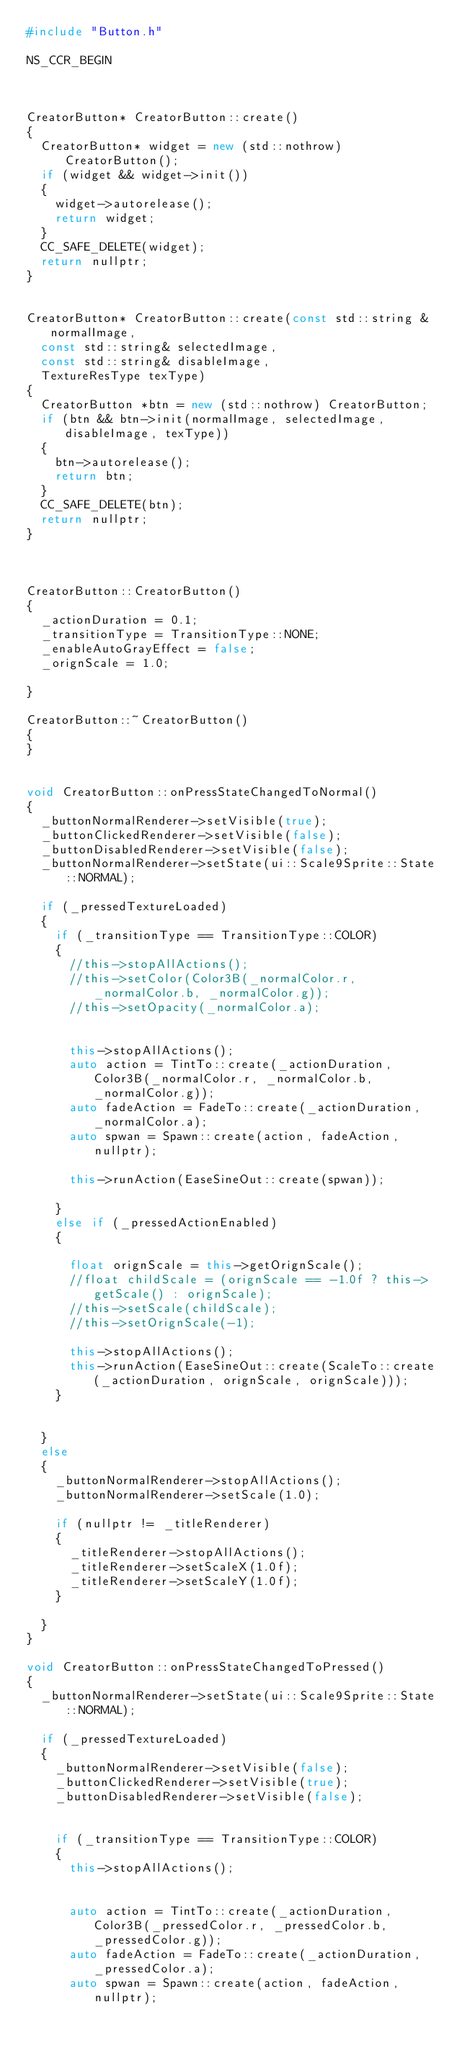<code> <loc_0><loc_0><loc_500><loc_500><_C++_>#include "Button.h"

NS_CCR_BEGIN



CreatorButton* CreatorButton::create()
{
	CreatorButton* widget = new (std::nothrow) CreatorButton();
	if (widget && widget->init())
	{
		widget->autorelease();
		return widget;
	}
	CC_SAFE_DELETE(widget);
	return nullptr;
}


CreatorButton* CreatorButton::create(const std::string &normalImage,
	const std::string& selectedImage,
	const std::string& disableImage,
	TextureResType texType)
{
	CreatorButton *btn = new (std::nothrow) CreatorButton;
	if (btn && btn->init(normalImage, selectedImage, disableImage, texType))
	{
		btn->autorelease();
		return btn;
	}
	CC_SAFE_DELETE(btn);
	return nullptr;
}



CreatorButton::CreatorButton()
{
	_actionDuration = 0.1;
	_transitionType = TransitionType::NONE;
	_enableAutoGrayEffect = false;
	_orignScale = 1.0;

}

CreatorButton::~CreatorButton()
{
}


void CreatorButton::onPressStateChangedToNormal()
{
	_buttonNormalRenderer->setVisible(true);
	_buttonClickedRenderer->setVisible(false);
	_buttonDisabledRenderer->setVisible(false);
	_buttonNormalRenderer->setState(ui::Scale9Sprite::State::NORMAL);

	if (_pressedTextureLoaded)
	{
		if (_transitionType == TransitionType::COLOR)
		{
			//this->stopAllActions();
			//this->setColor(Color3B(_normalColor.r, _normalColor.b, _normalColor.g));
			//this->setOpacity(_normalColor.a);


			this->stopAllActions();
			auto action = TintTo::create(_actionDuration, Color3B(_normalColor.r, _normalColor.b, _normalColor.g));
			auto fadeAction = FadeTo::create(_actionDuration, _normalColor.a);
			auto spwan = Spawn::create(action, fadeAction, nullptr);

			this->runAction(EaseSineOut::create(spwan));

		}
		else if (_pressedActionEnabled)
		{
			
			float orignScale = this->getOrignScale();
			//float childScale = (orignScale == -1.0f ? this->getScale() : orignScale);
			//this->setScale(childScale);
			//this->setOrignScale(-1);

			this->stopAllActions();
			this->runAction(EaseSineOut::create(ScaleTo::create(_actionDuration, orignScale, orignScale)));
		}


	}
	else
	{
		_buttonNormalRenderer->stopAllActions();
		_buttonNormalRenderer->setScale(1.0);

		if (nullptr != _titleRenderer)
		{
			_titleRenderer->stopAllActions();
			_titleRenderer->setScaleX(1.0f);
			_titleRenderer->setScaleY(1.0f);
		}

	}
}

void CreatorButton::onPressStateChangedToPressed()
{
	_buttonNormalRenderer->setState(ui::Scale9Sprite::State::NORMAL);

	if (_pressedTextureLoaded)
	{
		_buttonNormalRenderer->setVisible(false);
		_buttonClickedRenderer->setVisible(true);
		_buttonDisabledRenderer->setVisible(false);


		if (_transitionType == TransitionType::COLOR)
		{
			this->stopAllActions();


			auto action = TintTo::create(_actionDuration, Color3B(_pressedColor.r, _pressedColor.b, _pressedColor.g));
			auto fadeAction = FadeTo::create(_actionDuration, _pressedColor.a);
			auto spwan = Spawn::create(action, fadeAction, nullptr);
</code> 